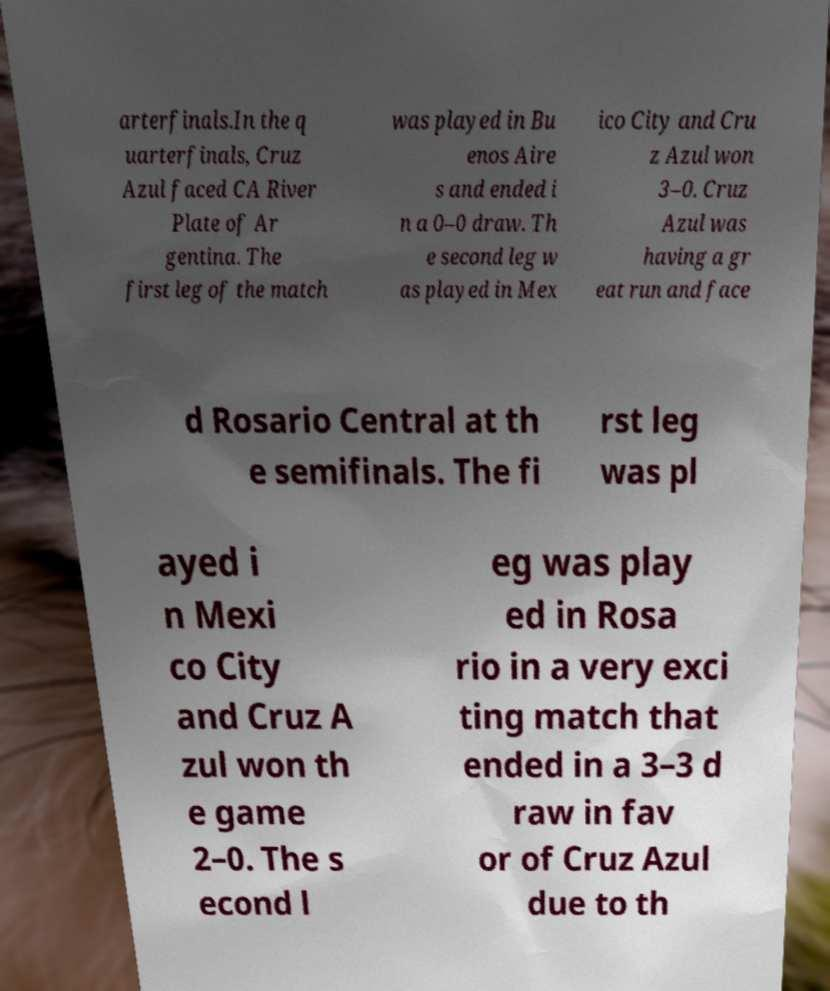What messages or text are displayed in this image? I need them in a readable, typed format. arterfinals.In the q uarterfinals, Cruz Azul faced CA River Plate of Ar gentina. The first leg of the match was played in Bu enos Aire s and ended i n a 0–0 draw. Th e second leg w as played in Mex ico City and Cru z Azul won 3–0. Cruz Azul was having a gr eat run and face d Rosario Central at th e semifinals. The fi rst leg was pl ayed i n Mexi co City and Cruz A zul won th e game 2–0. The s econd l eg was play ed in Rosa rio in a very exci ting match that ended in a 3–3 d raw in fav or of Cruz Azul due to th 